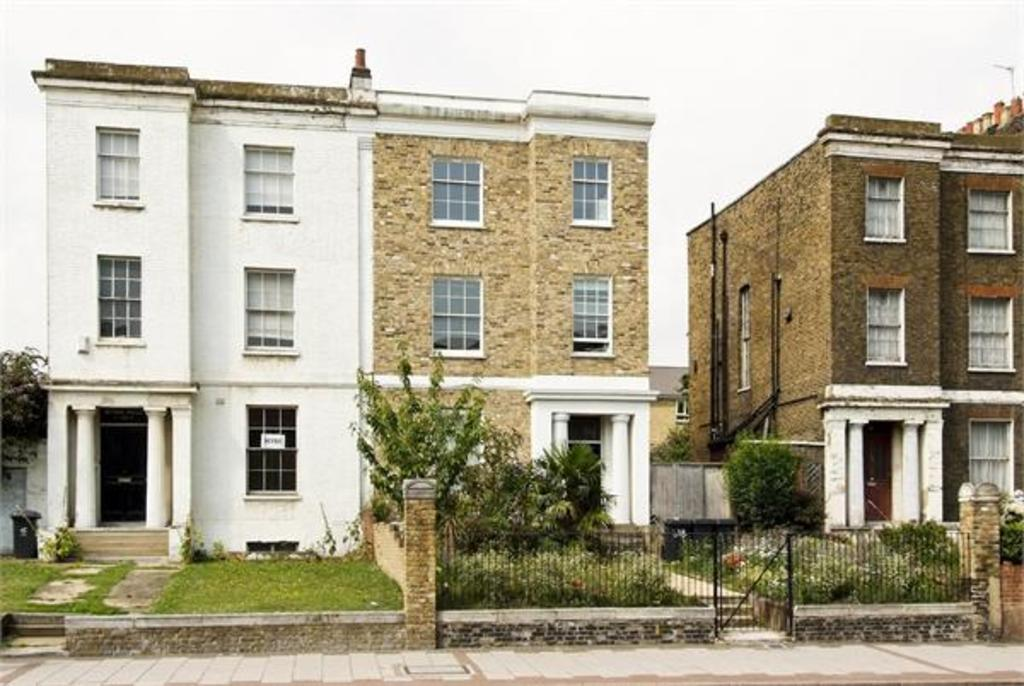What type of structures can be seen in the image? There are buildings in the image. What natural elements are present in the image? There are trees and plants in the image. What type of barrier can be seen in the image? There is a fence in the image. What type of path is visible in the image? There is a sideway in the image. What color is the shirt worn by the rose in the image? There is no rose or shirt present in the image. 